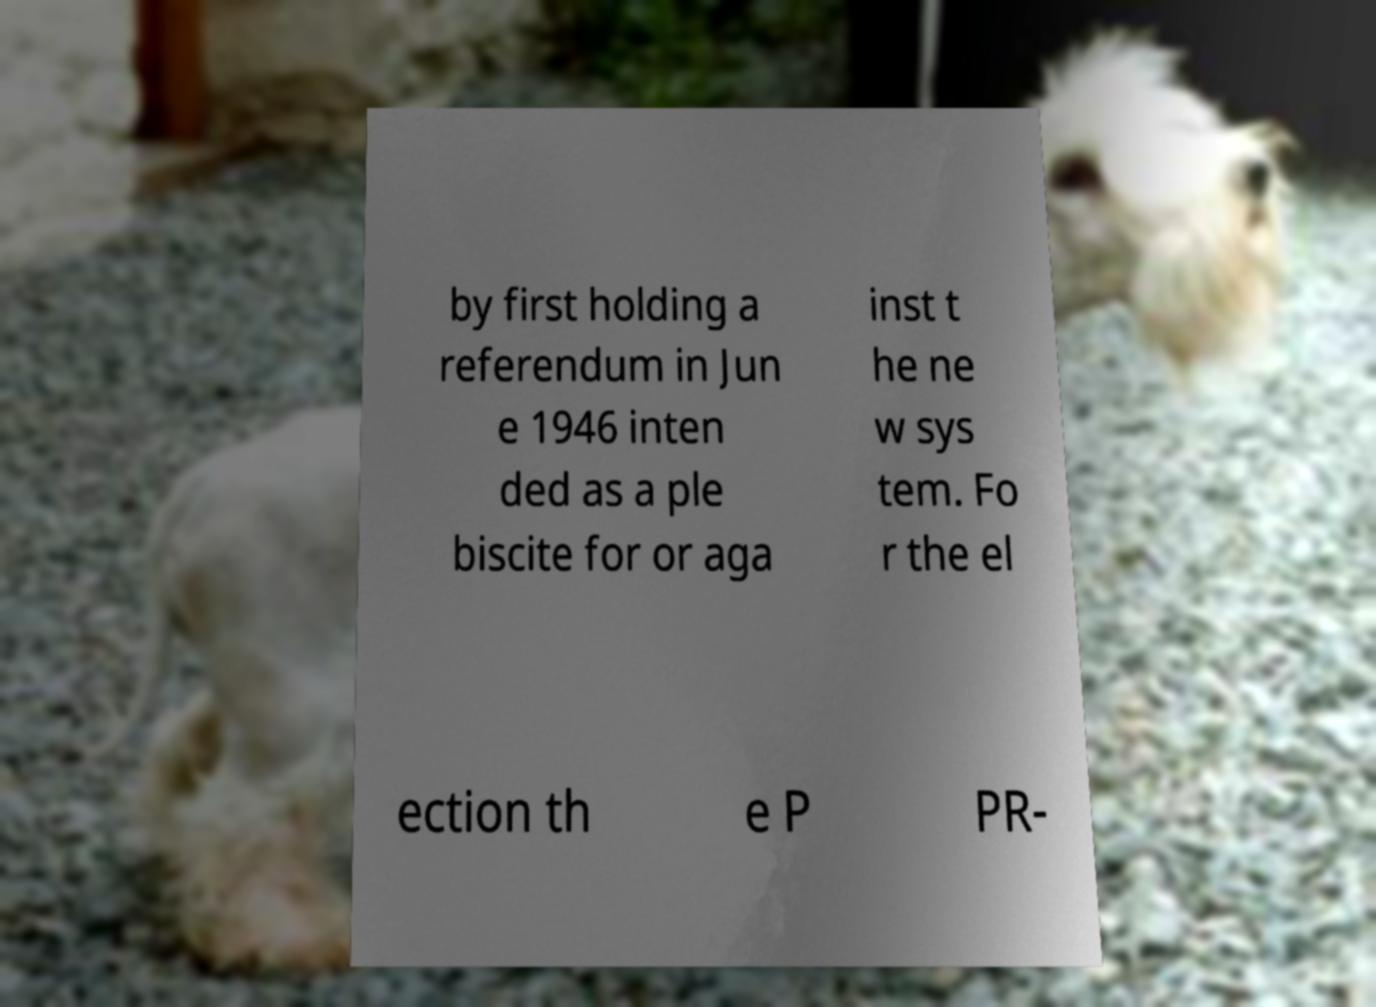I need the written content from this picture converted into text. Can you do that? by first holding a referendum in Jun e 1946 inten ded as a ple biscite for or aga inst t he ne w sys tem. Fo r the el ection th e P PR- 